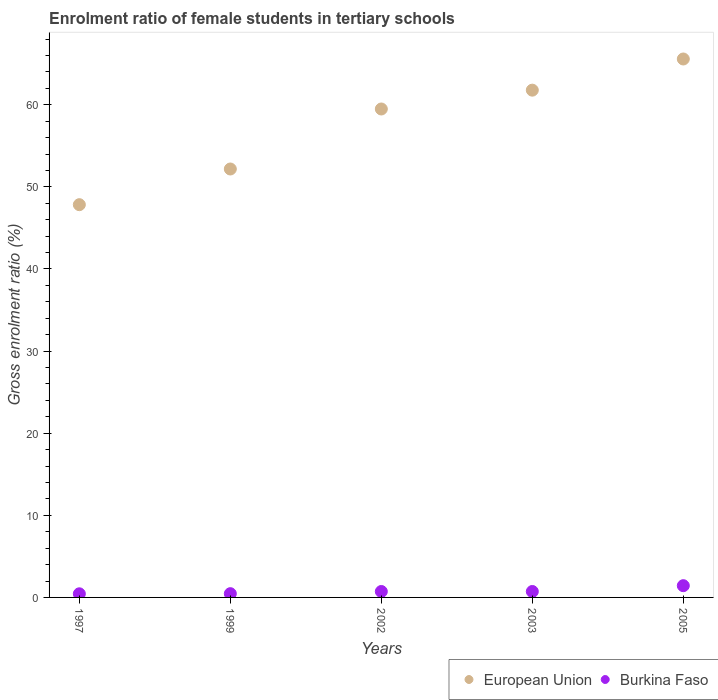How many different coloured dotlines are there?
Provide a succinct answer. 2. Is the number of dotlines equal to the number of legend labels?
Offer a very short reply. Yes. What is the enrolment ratio of female students in tertiary schools in Burkina Faso in 2005?
Provide a succinct answer. 1.43. Across all years, what is the maximum enrolment ratio of female students in tertiary schools in European Union?
Make the answer very short. 65.58. Across all years, what is the minimum enrolment ratio of female students in tertiary schools in Burkina Faso?
Provide a short and direct response. 0.44. In which year was the enrolment ratio of female students in tertiary schools in Burkina Faso maximum?
Your response must be concise. 2005. What is the total enrolment ratio of female students in tertiary schools in European Union in the graph?
Provide a short and direct response. 286.86. What is the difference between the enrolment ratio of female students in tertiary schools in European Union in 2003 and that in 2005?
Provide a succinct answer. -3.8. What is the difference between the enrolment ratio of female students in tertiary schools in European Union in 2002 and the enrolment ratio of female students in tertiary schools in Burkina Faso in 2003?
Make the answer very short. 58.77. What is the average enrolment ratio of female students in tertiary schools in Burkina Faso per year?
Offer a very short reply. 0.75. In the year 2003, what is the difference between the enrolment ratio of female students in tertiary schools in Burkina Faso and enrolment ratio of female students in tertiary schools in European Union?
Your answer should be compact. -61.06. In how many years, is the enrolment ratio of female students in tertiary schools in European Union greater than 22 %?
Keep it short and to the point. 5. What is the ratio of the enrolment ratio of female students in tertiary schools in European Union in 1999 to that in 2005?
Your answer should be very brief. 0.8. What is the difference between the highest and the second highest enrolment ratio of female students in tertiary schools in Burkina Faso?
Provide a succinct answer. 0.71. What is the difference between the highest and the lowest enrolment ratio of female students in tertiary schools in Burkina Faso?
Offer a terse response. 0.99. In how many years, is the enrolment ratio of female students in tertiary schools in European Union greater than the average enrolment ratio of female students in tertiary schools in European Union taken over all years?
Keep it short and to the point. 3. Is the sum of the enrolment ratio of female students in tertiary schools in Burkina Faso in 1997 and 2003 greater than the maximum enrolment ratio of female students in tertiary schools in European Union across all years?
Ensure brevity in your answer.  No. Is the enrolment ratio of female students in tertiary schools in European Union strictly greater than the enrolment ratio of female students in tertiary schools in Burkina Faso over the years?
Your answer should be compact. Yes. Is the enrolment ratio of female students in tertiary schools in Burkina Faso strictly less than the enrolment ratio of female students in tertiary schools in European Union over the years?
Provide a short and direct response. Yes. How many dotlines are there?
Make the answer very short. 2. Are the values on the major ticks of Y-axis written in scientific E-notation?
Your answer should be compact. No. How many legend labels are there?
Provide a succinct answer. 2. What is the title of the graph?
Provide a succinct answer. Enrolment ratio of female students in tertiary schools. Does "Brazil" appear as one of the legend labels in the graph?
Offer a terse response. No. What is the Gross enrolment ratio (%) in European Union in 1997?
Your answer should be very brief. 47.83. What is the Gross enrolment ratio (%) in Burkina Faso in 1997?
Your answer should be compact. 0.44. What is the Gross enrolment ratio (%) of European Union in 1999?
Provide a succinct answer. 52.18. What is the Gross enrolment ratio (%) of Burkina Faso in 1999?
Ensure brevity in your answer.  0.46. What is the Gross enrolment ratio (%) of European Union in 2002?
Make the answer very short. 59.49. What is the Gross enrolment ratio (%) of Burkina Faso in 2002?
Provide a short and direct response. 0.72. What is the Gross enrolment ratio (%) in European Union in 2003?
Give a very brief answer. 61.78. What is the Gross enrolment ratio (%) in Burkina Faso in 2003?
Keep it short and to the point. 0.72. What is the Gross enrolment ratio (%) of European Union in 2005?
Provide a short and direct response. 65.58. What is the Gross enrolment ratio (%) in Burkina Faso in 2005?
Provide a short and direct response. 1.43. Across all years, what is the maximum Gross enrolment ratio (%) of European Union?
Keep it short and to the point. 65.58. Across all years, what is the maximum Gross enrolment ratio (%) in Burkina Faso?
Your answer should be very brief. 1.43. Across all years, what is the minimum Gross enrolment ratio (%) of European Union?
Offer a terse response. 47.83. Across all years, what is the minimum Gross enrolment ratio (%) of Burkina Faso?
Give a very brief answer. 0.44. What is the total Gross enrolment ratio (%) of European Union in the graph?
Make the answer very short. 286.86. What is the total Gross enrolment ratio (%) in Burkina Faso in the graph?
Provide a succinct answer. 3.77. What is the difference between the Gross enrolment ratio (%) in European Union in 1997 and that in 1999?
Your answer should be very brief. -4.35. What is the difference between the Gross enrolment ratio (%) of Burkina Faso in 1997 and that in 1999?
Keep it short and to the point. -0.02. What is the difference between the Gross enrolment ratio (%) of European Union in 1997 and that in 2002?
Provide a succinct answer. -11.65. What is the difference between the Gross enrolment ratio (%) in Burkina Faso in 1997 and that in 2002?
Offer a terse response. -0.28. What is the difference between the Gross enrolment ratio (%) of European Union in 1997 and that in 2003?
Offer a very short reply. -13.95. What is the difference between the Gross enrolment ratio (%) in Burkina Faso in 1997 and that in 2003?
Give a very brief answer. -0.28. What is the difference between the Gross enrolment ratio (%) in European Union in 1997 and that in 2005?
Make the answer very short. -17.74. What is the difference between the Gross enrolment ratio (%) in Burkina Faso in 1997 and that in 2005?
Provide a succinct answer. -0.99. What is the difference between the Gross enrolment ratio (%) in European Union in 1999 and that in 2002?
Provide a short and direct response. -7.31. What is the difference between the Gross enrolment ratio (%) in Burkina Faso in 1999 and that in 2002?
Your answer should be very brief. -0.26. What is the difference between the Gross enrolment ratio (%) of European Union in 1999 and that in 2003?
Offer a terse response. -9.6. What is the difference between the Gross enrolment ratio (%) in Burkina Faso in 1999 and that in 2003?
Offer a terse response. -0.27. What is the difference between the Gross enrolment ratio (%) of European Union in 1999 and that in 2005?
Your response must be concise. -13.4. What is the difference between the Gross enrolment ratio (%) in Burkina Faso in 1999 and that in 2005?
Provide a short and direct response. -0.97. What is the difference between the Gross enrolment ratio (%) of European Union in 2002 and that in 2003?
Give a very brief answer. -2.29. What is the difference between the Gross enrolment ratio (%) in Burkina Faso in 2002 and that in 2003?
Provide a short and direct response. -0. What is the difference between the Gross enrolment ratio (%) of European Union in 2002 and that in 2005?
Provide a succinct answer. -6.09. What is the difference between the Gross enrolment ratio (%) in Burkina Faso in 2002 and that in 2005?
Your answer should be very brief. -0.71. What is the difference between the Gross enrolment ratio (%) in European Union in 2003 and that in 2005?
Provide a succinct answer. -3.8. What is the difference between the Gross enrolment ratio (%) of Burkina Faso in 2003 and that in 2005?
Your answer should be compact. -0.71. What is the difference between the Gross enrolment ratio (%) in European Union in 1997 and the Gross enrolment ratio (%) in Burkina Faso in 1999?
Provide a short and direct response. 47.38. What is the difference between the Gross enrolment ratio (%) in European Union in 1997 and the Gross enrolment ratio (%) in Burkina Faso in 2002?
Keep it short and to the point. 47.11. What is the difference between the Gross enrolment ratio (%) in European Union in 1997 and the Gross enrolment ratio (%) in Burkina Faso in 2003?
Provide a short and direct response. 47.11. What is the difference between the Gross enrolment ratio (%) of European Union in 1997 and the Gross enrolment ratio (%) of Burkina Faso in 2005?
Your answer should be very brief. 46.4. What is the difference between the Gross enrolment ratio (%) in European Union in 1999 and the Gross enrolment ratio (%) in Burkina Faso in 2002?
Ensure brevity in your answer.  51.46. What is the difference between the Gross enrolment ratio (%) of European Union in 1999 and the Gross enrolment ratio (%) of Burkina Faso in 2003?
Make the answer very short. 51.46. What is the difference between the Gross enrolment ratio (%) of European Union in 1999 and the Gross enrolment ratio (%) of Burkina Faso in 2005?
Offer a very short reply. 50.75. What is the difference between the Gross enrolment ratio (%) of European Union in 2002 and the Gross enrolment ratio (%) of Burkina Faso in 2003?
Give a very brief answer. 58.77. What is the difference between the Gross enrolment ratio (%) of European Union in 2002 and the Gross enrolment ratio (%) of Burkina Faso in 2005?
Your response must be concise. 58.06. What is the difference between the Gross enrolment ratio (%) of European Union in 2003 and the Gross enrolment ratio (%) of Burkina Faso in 2005?
Ensure brevity in your answer.  60.35. What is the average Gross enrolment ratio (%) in European Union per year?
Provide a short and direct response. 57.37. What is the average Gross enrolment ratio (%) in Burkina Faso per year?
Your answer should be compact. 0.75. In the year 1997, what is the difference between the Gross enrolment ratio (%) of European Union and Gross enrolment ratio (%) of Burkina Faso?
Provide a succinct answer. 47.39. In the year 1999, what is the difference between the Gross enrolment ratio (%) of European Union and Gross enrolment ratio (%) of Burkina Faso?
Make the answer very short. 51.72. In the year 2002, what is the difference between the Gross enrolment ratio (%) of European Union and Gross enrolment ratio (%) of Burkina Faso?
Offer a terse response. 58.77. In the year 2003, what is the difference between the Gross enrolment ratio (%) in European Union and Gross enrolment ratio (%) in Burkina Faso?
Your answer should be very brief. 61.06. In the year 2005, what is the difference between the Gross enrolment ratio (%) in European Union and Gross enrolment ratio (%) in Burkina Faso?
Your answer should be very brief. 64.15. What is the ratio of the Gross enrolment ratio (%) in Burkina Faso in 1997 to that in 1999?
Your answer should be very brief. 0.97. What is the ratio of the Gross enrolment ratio (%) of European Union in 1997 to that in 2002?
Keep it short and to the point. 0.8. What is the ratio of the Gross enrolment ratio (%) of Burkina Faso in 1997 to that in 2002?
Your answer should be compact. 0.61. What is the ratio of the Gross enrolment ratio (%) in European Union in 1997 to that in 2003?
Offer a terse response. 0.77. What is the ratio of the Gross enrolment ratio (%) of Burkina Faso in 1997 to that in 2003?
Make the answer very short. 0.61. What is the ratio of the Gross enrolment ratio (%) of European Union in 1997 to that in 2005?
Provide a short and direct response. 0.73. What is the ratio of the Gross enrolment ratio (%) in Burkina Faso in 1997 to that in 2005?
Provide a succinct answer. 0.31. What is the ratio of the Gross enrolment ratio (%) of European Union in 1999 to that in 2002?
Your response must be concise. 0.88. What is the ratio of the Gross enrolment ratio (%) of Burkina Faso in 1999 to that in 2002?
Ensure brevity in your answer.  0.63. What is the ratio of the Gross enrolment ratio (%) of European Union in 1999 to that in 2003?
Make the answer very short. 0.84. What is the ratio of the Gross enrolment ratio (%) of Burkina Faso in 1999 to that in 2003?
Provide a short and direct response. 0.63. What is the ratio of the Gross enrolment ratio (%) of European Union in 1999 to that in 2005?
Offer a terse response. 0.8. What is the ratio of the Gross enrolment ratio (%) of Burkina Faso in 1999 to that in 2005?
Your answer should be very brief. 0.32. What is the ratio of the Gross enrolment ratio (%) in European Union in 2002 to that in 2003?
Offer a very short reply. 0.96. What is the ratio of the Gross enrolment ratio (%) in Burkina Faso in 2002 to that in 2003?
Ensure brevity in your answer.  1. What is the ratio of the Gross enrolment ratio (%) of European Union in 2002 to that in 2005?
Your response must be concise. 0.91. What is the ratio of the Gross enrolment ratio (%) in Burkina Faso in 2002 to that in 2005?
Your answer should be very brief. 0.5. What is the ratio of the Gross enrolment ratio (%) in European Union in 2003 to that in 2005?
Your answer should be very brief. 0.94. What is the ratio of the Gross enrolment ratio (%) in Burkina Faso in 2003 to that in 2005?
Provide a short and direct response. 0.51. What is the difference between the highest and the second highest Gross enrolment ratio (%) in European Union?
Make the answer very short. 3.8. What is the difference between the highest and the second highest Gross enrolment ratio (%) of Burkina Faso?
Keep it short and to the point. 0.71. What is the difference between the highest and the lowest Gross enrolment ratio (%) in European Union?
Offer a terse response. 17.74. What is the difference between the highest and the lowest Gross enrolment ratio (%) in Burkina Faso?
Make the answer very short. 0.99. 